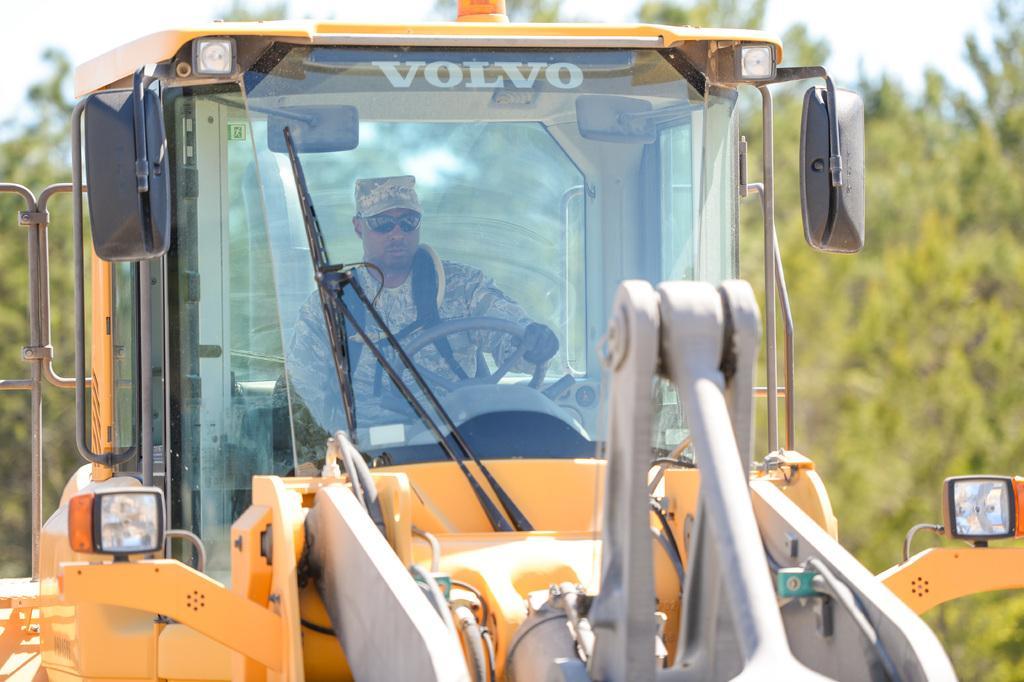Could you give a brief overview of what you see in this image? This picture is highlighted with a vehicle which is yellow in colour and i guess it's an excavator. Inside of the vehicle there is a man sitting and driving. This man is wearing a cap and he is wearing gloves to his hands. He wore spectacles. At the backside of the vehicle there are trees. On the top of the picture we can see a sky and it seems like a sunny day. 